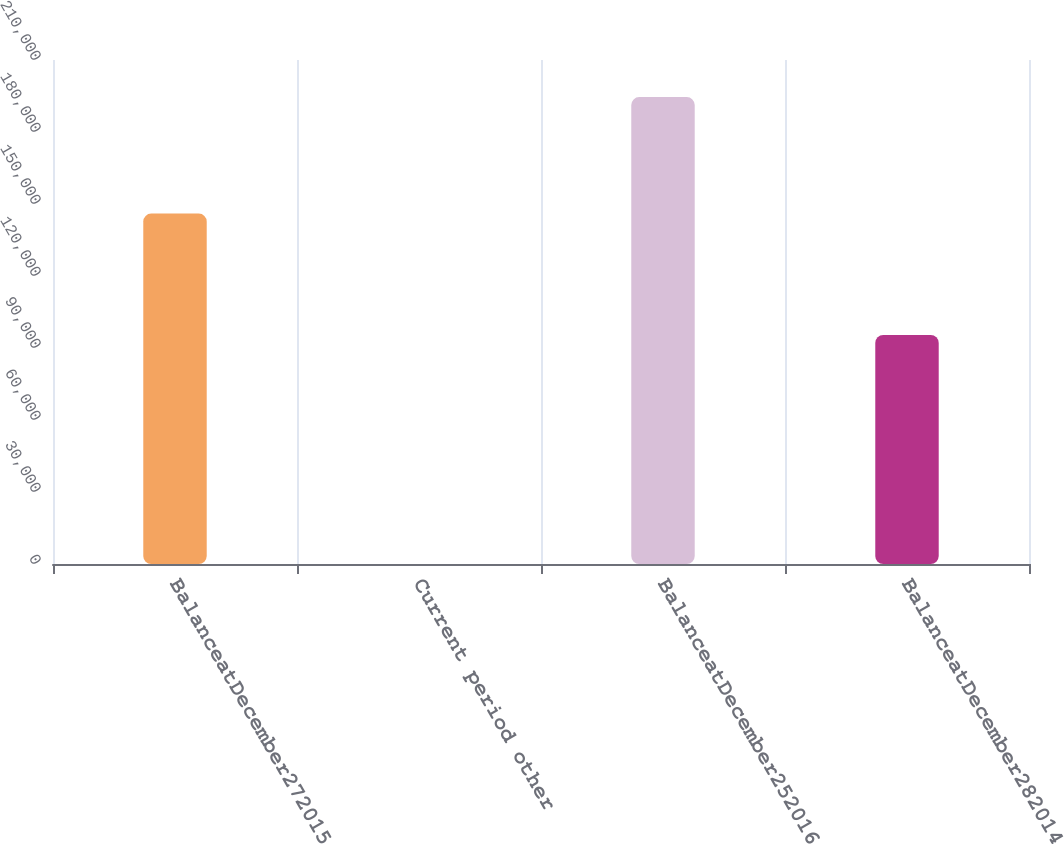<chart> <loc_0><loc_0><loc_500><loc_500><bar_chart><fcel>BalanceatDecember272015<fcel>Current period other<fcel>BalanceatDecember252016<fcel>BalanceatDecember282014<nl><fcel>146001<fcel>52<fcel>194570<fcel>95454<nl></chart> 